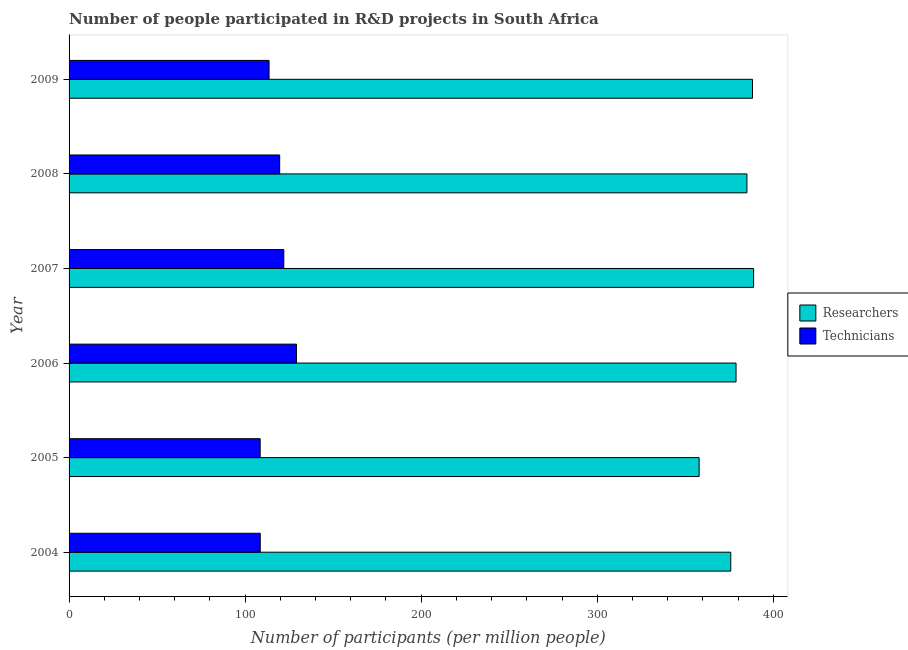How many different coloured bars are there?
Give a very brief answer. 2. How many bars are there on the 1st tick from the bottom?
Keep it short and to the point. 2. What is the number of researchers in 2004?
Offer a very short reply. 375.83. Across all years, what is the maximum number of researchers?
Offer a terse response. 388.79. Across all years, what is the minimum number of researchers?
Keep it short and to the point. 357.85. In which year was the number of technicians minimum?
Give a very brief answer. 2005. What is the total number of technicians in the graph?
Ensure brevity in your answer.  701.43. What is the difference between the number of researchers in 2004 and that in 2007?
Offer a terse response. -12.96. What is the difference between the number of researchers in 2004 and the number of technicians in 2008?
Your answer should be compact. 256.21. What is the average number of researchers per year?
Ensure brevity in your answer.  379.07. In the year 2006, what is the difference between the number of technicians and number of researchers?
Keep it short and to the point. -249.68. In how many years, is the number of researchers greater than 20 ?
Give a very brief answer. 6. What is the ratio of the number of technicians in 2004 to that in 2005?
Provide a short and direct response. 1. Is the number of technicians in 2007 less than that in 2009?
Offer a very short reply. No. What is the difference between the highest and the second highest number of researchers?
Give a very brief answer. 0.63. What is the difference between the highest and the lowest number of technicians?
Offer a terse response. 20.6. Is the sum of the number of researchers in 2005 and 2006 greater than the maximum number of technicians across all years?
Make the answer very short. Yes. What does the 1st bar from the top in 2008 represents?
Offer a terse response. Technicians. What does the 2nd bar from the bottom in 2007 represents?
Offer a terse response. Technicians. How many bars are there?
Keep it short and to the point. 12. Are all the bars in the graph horizontal?
Make the answer very short. Yes. Are the values on the major ticks of X-axis written in scientific E-notation?
Offer a terse response. No. Does the graph contain grids?
Your response must be concise. No. Where does the legend appear in the graph?
Provide a succinct answer. Center right. How many legend labels are there?
Offer a terse response. 2. What is the title of the graph?
Offer a very short reply. Number of people participated in R&D projects in South Africa. Does "By country of origin" appear as one of the legend labels in the graph?
Your answer should be very brief. No. What is the label or title of the X-axis?
Give a very brief answer. Number of participants (per million people). What is the Number of participants (per million people) in Researchers in 2004?
Your answer should be very brief. 375.83. What is the Number of participants (per million people) in Technicians in 2004?
Keep it short and to the point. 108.58. What is the Number of participants (per million people) in Researchers in 2005?
Your answer should be compact. 357.85. What is the Number of participants (per million people) of Technicians in 2005?
Your response must be concise. 108.54. What is the Number of participants (per million people) of Researchers in 2006?
Make the answer very short. 378.82. What is the Number of participants (per million people) of Technicians in 2006?
Provide a succinct answer. 129.14. What is the Number of participants (per million people) in Researchers in 2007?
Keep it short and to the point. 388.79. What is the Number of participants (per million people) of Technicians in 2007?
Offer a very short reply. 121.96. What is the Number of participants (per million people) in Researchers in 2008?
Your answer should be very brief. 385. What is the Number of participants (per million people) of Technicians in 2008?
Your response must be concise. 119.61. What is the Number of participants (per million people) of Researchers in 2009?
Your answer should be very brief. 388.16. What is the Number of participants (per million people) of Technicians in 2009?
Offer a very short reply. 113.59. Across all years, what is the maximum Number of participants (per million people) of Researchers?
Provide a succinct answer. 388.79. Across all years, what is the maximum Number of participants (per million people) in Technicians?
Your response must be concise. 129.14. Across all years, what is the minimum Number of participants (per million people) of Researchers?
Provide a succinct answer. 357.85. Across all years, what is the minimum Number of participants (per million people) in Technicians?
Your answer should be compact. 108.54. What is the total Number of participants (per million people) in Researchers in the graph?
Offer a terse response. 2274.44. What is the total Number of participants (per million people) of Technicians in the graph?
Make the answer very short. 701.43. What is the difference between the Number of participants (per million people) of Researchers in 2004 and that in 2005?
Offer a terse response. 17.98. What is the difference between the Number of participants (per million people) in Technicians in 2004 and that in 2005?
Your response must be concise. 0.04. What is the difference between the Number of participants (per million people) in Researchers in 2004 and that in 2006?
Keep it short and to the point. -3. What is the difference between the Number of participants (per million people) in Technicians in 2004 and that in 2006?
Ensure brevity in your answer.  -20.56. What is the difference between the Number of participants (per million people) of Researchers in 2004 and that in 2007?
Your response must be concise. -12.96. What is the difference between the Number of participants (per million people) of Technicians in 2004 and that in 2007?
Your response must be concise. -13.38. What is the difference between the Number of participants (per million people) in Researchers in 2004 and that in 2008?
Provide a short and direct response. -9.18. What is the difference between the Number of participants (per million people) of Technicians in 2004 and that in 2008?
Keep it short and to the point. -11.03. What is the difference between the Number of participants (per million people) in Researchers in 2004 and that in 2009?
Provide a succinct answer. -12.33. What is the difference between the Number of participants (per million people) of Technicians in 2004 and that in 2009?
Offer a very short reply. -5.01. What is the difference between the Number of participants (per million people) of Researchers in 2005 and that in 2006?
Provide a short and direct response. -20.97. What is the difference between the Number of participants (per million people) of Technicians in 2005 and that in 2006?
Your answer should be very brief. -20.6. What is the difference between the Number of participants (per million people) in Researchers in 2005 and that in 2007?
Provide a succinct answer. -30.94. What is the difference between the Number of participants (per million people) of Technicians in 2005 and that in 2007?
Give a very brief answer. -13.42. What is the difference between the Number of participants (per million people) in Researchers in 2005 and that in 2008?
Provide a short and direct response. -27.15. What is the difference between the Number of participants (per million people) in Technicians in 2005 and that in 2008?
Provide a succinct answer. -11.07. What is the difference between the Number of participants (per million people) of Researchers in 2005 and that in 2009?
Ensure brevity in your answer.  -30.31. What is the difference between the Number of participants (per million people) of Technicians in 2005 and that in 2009?
Make the answer very short. -5.05. What is the difference between the Number of participants (per million people) of Researchers in 2006 and that in 2007?
Make the answer very short. -9.97. What is the difference between the Number of participants (per million people) in Technicians in 2006 and that in 2007?
Your answer should be compact. 7.19. What is the difference between the Number of participants (per million people) of Researchers in 2006 and that in 2008?
Your answer should be very brief. -6.18. What is the difference between the Number of participants (per million people) in Technicians in 2006 and that in 2008?
Your response must be concise. 9.53. What is the difference between the Number of participants (per million people) of Researchers in 2006 and that in 2009?
Provide a succinct answer. -9.34. What is the difference between the Number of participants (per million people) of Technicians in 2006 and that in 2009?
Ensure brevity in your answer.  15.55. What is the difference between the Number of participants (per million people) in Researchers in 2007 and that in 2008?
Offer a very short reply. 3.79. What is the difference between the Number of participants (per million people) of Technicians in 2007 and that in 2008?
Provide a succinct answer. 2.34. What is the difference between the Number of participants (per million people) in Researchers in 2007 and that in 2009?
Provide a short and direct response. 0.63. What is the difference between the Number of participants (per million people) of Technicians in 2007 and that in 2009?
Your answer should be very brief. 8.37. What is the difference between the Number of participants (per million people) in Researchers in 2008 and that in 2009?
Make the answer very short. -3.16. What is the difference between the Number of participants (per million people) in Technicians in 2008 and that in 2009?
Ensure brevity in your answer.  6.02. What is the difference between the Number of participants (per million people) in Researchers in 2004 and the Number of participants (per million people) in Technicians in 2005?
Your response must be concise. 267.28. What is the difference between the Number of participants (per million people) of Researchers in 2004 and the Number of participants (per million people) of Technicians in 2006?
Offer a terse response. 246.68. What is the difference between the Number of participants (per million people) in Researchers in 2004 and the Number of participants (per million people) in Technicians in 2007?
Offer a terse response. 253.87. What is the difference between the Number of participants (per million people) in Researchers in 2004 and the Number of participants (per million people) in Technicians in 2008?
Offer a very short reply. 256.21. What is the difference between the Number of participants (per million people) of Researchers in 2004 and the Number of participants (per million people) of Technicians in 2009?
Your response must be concise. 262.24. What is the difference between the Number of participants (per million people) of Researchers in 2005 and the Number of participants (per million people) of Technicians in 2006?
Make the answer very short. 228.7. What is the difference between the Number of participants (per million people) of Researchers in 2005 and the Number of participants (per million people) of Technicians in 2007?
Offer a terse response. 235.89. What is the difference between the Number of participants (per million people) of Researchers in 2005 and the Number of participants (per million people) of Technicians in 2008?
Provide a short and direct response. 238.23. What is the difference between the Number of participants (per million people) of Researchers in 2005 and the Number of participants (per million people) of Technicians in 2009?
Your answer should be compact. 244.26. What is the difference between the Number of participants (per million people) of Researchers in 2006 and the Number of participants (per million people) of Technicians in 2007?
Provide a short and direct response. 256.86. What is the difference between the Number of participants (per million people) of Researchers in 2006 and the Number of participants (per million people) of Technicians in 2008?
Offer a very short reply. 259.21. What is the difference between the Number of participants (per million people) of Researchers in 2006 and the Number of participants (per million people) of Technicians in 2009?
Provide a short and direct response. 265.23. What is the difference between the Number of participants (per million people) in Researchers in 2007 and the Number of participants (per million people) in Technicians in 2008?
Provide a short and direct response. 269.17. What is the difference between the Number of participants (per million people) of Researchers in 2007 and the Number of participants (per million people) of Technicians in 2009?
Provide a short and direct response. 275.2. What is the difference between the Number of participants (per million people) of Researchers in 2008 and the Number of participants (per million people) of Technicians in 2009?
Provide a short and direct response. 271.41. What is the average Number of participants (per million people) in Researchers per year?
Make the answer very short. 379.07. What is the average Number of participants (per million people) in Technicians per year?
Ensure brevity in your answer.  116.9. In the year 2004, what is the difference between the Number of participants (per million people) in Researchers and Number of participants (per million people) in Technicians?
Offer a very short reply. 267.25. In the year 2005, what is the difference between the Number of participants (per million people) in Researchers and Number of participants (per million people) in Technicians?
Ensure brevity in your answer.  249.31. In the year 2006, what is the difference between the Number of participants (per million people) in Researchers and Number of participants (per million people) in Technicians?
Your response must be concise. 249.68. In the year 2007, what is the difference between the Number of participants (per million people) of Researchers and Number of participants (per million people) of Technicians?
Your answer should be very brief. 266.83. In the year 2008, what is the difference between the Number of participants (per million people) of Researchers and Number of participants (per million people) of Technicians?
Give a very brief answer. 265.39. In the year 2009, what is the difference between the Number of participants (per million people) in Researchers and Number of participants (per million people) in Technicians?
Offer a terse response. 274.57. What is the ratio of the Number of participants (per million people) of Researchers in 2004 to that in 2005?
Ensure brevity in your answer.  1.05. What is the ratio of the Number of participants (per million people) in Technicians in 2004 to that in 2006?
Your answer should be compact. 0.84. What is the ratio of the Number of participants (per million people) of Researchers in 2004 to that in 2007?
Keep it short and to the point. 0.97. What is the ratio of the Number of participants (per million people) in Technicians in 2004 to that in 2007?
Your answer should be compact. 0.89. What is the ratio of the Number of participants (per million people) of Researchers in 2004 to that in 2008?
Provide a succinct answer. 0.98. What is the ratio of the Number of participants (per million people) of Technicians in 2004 to that in 2008?
Keep it short and to the point. 0.91. What is the ratio of the Number of participants (per million people) in Researchers in 2004 to that in 2009?
Give a very brief answer. 0.97. What is the ratio of the Number of participants (per million people) in Technicians in 2004 to that in 2009?
Provide a succinct answer. 0.96. What is the ratio of the Number of participants (per million people) in Researchers in 2005 to that in 2006?
Your answer should be very brief. 0.94. What is the ratio of the Number of participants (per million people) of Technicians in 2005 to that in 2006?
Make the answer very short. 0.84. What is the ratio of the Number of participants (per million people) in Researchers in 2005 to that in 2007?
Your answer should be very brief. 0.92. What is the ratio of the Number of participants (per million people) of Technicians in 2005 to that in 2007?
Offer a terse response. 0.89. What is the ratio of the Number of participants (per million people) of Researchers in 2005 to that in 2008?
Provide a short and direct response. 0.93. What is the ratio of the Number of participants (per million people) of Technicians in 2005 to that in 2008?
Ensure brevity in your answer.  0.91. What is the ratio of the Number of participants (per million people) in Researchers in 2005 to that in 2009?
Keep it short and to the point. 0.92. What is the ratio of the Number of participants (per million people) in Technicians in 2005 to that in 2009?
Your answer should be very brief. 0.96. What is the ratio of the Number of participants (per million people) in Researchers in 2006 to that in 2007?
Your answer should be compact. 0.97. What is the ratio of the Number of participants (per million people) of Technicians in 2006 to that in 2007?
Your answer should be very brief. 1.06. What is the ratio of the Number of participants (per million people) of Researchers in 2006 to that in 2008?
Offer a very short reply. 0.98. What is the ratio of the Number of participants (per million people) of Technicians in 2006 to that in 2008?
Your answer should be compact. 1.08. What is the ratio of the Number of participants (per million people) in Researchers in 2006 to that in 2009?
Provide a short and direct response. 0.98. What is the ratio of the Number of participants (per million people) of Technicians in 2006 to that in 2009?
Your answer should be compact. 1.14. What is the ratio of the Number of participants (per million people) of Researchers in 2007 to that in 2008?
Your answer should be very brief. 1.01. What is the ratio of the Number of participants (per million people) in Technicians in 2007 to that in 2008?
Your answer should be very brief. 1.02. What is the ratio of the Number of participants (per million people) in Technicians in 2007 to that in 2009?
Keep it short and to the point. 1.07. What is the ratio of the Number of participants (per million people) in Researchers in 2008 to that in 2009?
Give a very brief answer. 0.99. What is the ratio of the Number of participants (per million people) of Technicians in 2008 to that in 2009?
Provide a short and direct response. 1.05. What is the difference between the highest and the second highest Number of participants (per million people) in Researchers?
Provide a succinct answer. 0.63. What is the difference between the highest and the second highest Number of participants (per million people) in Technicians?
Your response must be concise. 7.19. What is the difference between the highest and the lowest Number of participants (per million people) of Researchers?
Provide a short and direct response. 30.94. What is the difference between the highest and the lowest Number of participants (per million people) of Technicians?
Your answer should be compact. 20.6. 